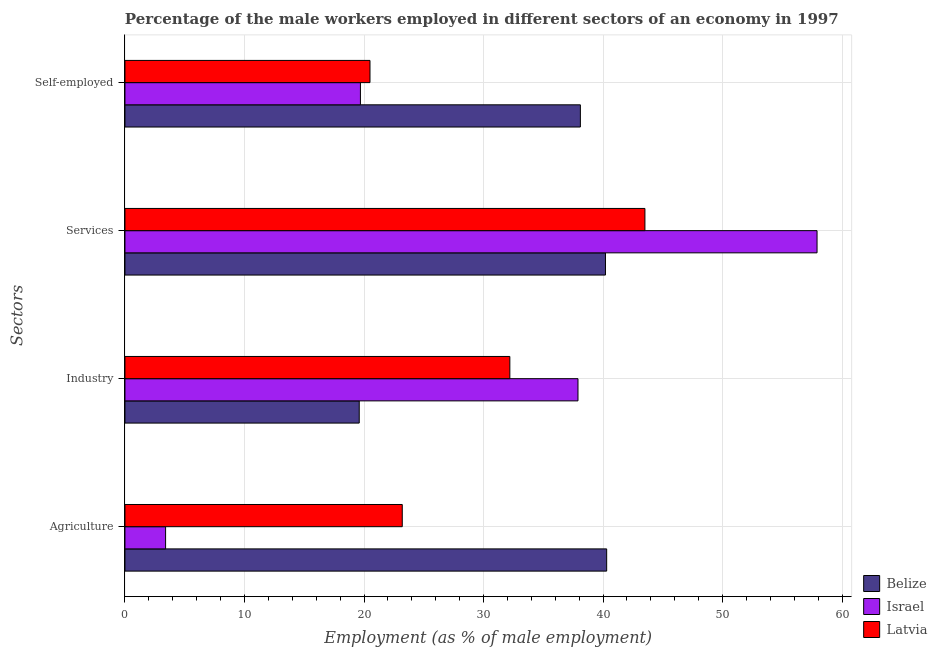How many groups of bars are there?
Offer a terse response. 4. Are the number of bars on each tick of the Y-axis equal?
Make the answer very short. Yes. How many bars are there on the 2nd tick from the bottom?
Provide a succinct answer. 3. What is the label of the 3rd group of bars from the top?
Your response must be concise. Industry. What is the percentage of self employed male workers in Latvia?
Give a very brief answer. 20.5. Across all countries, what is the maximum percentage of male workers in services?
Make the answer very short. 57.9. Across all countries, what is the minimum percentage of male workers in industry?
Your answer should be very brief. 19.6. In which country was the percentage of self employed male workers maximum?
Ensure brevity in your answer.  Belize. In which country was the percentage of male workers in agriculture minimum?
Offer a terse response. Israel. What is the total percentage of male workers in agriculture in the graph?
Ensure brevity in your answer.  66.9. What is the difference between the percentage of male workers in industry in Belize and that in Latvia?
Provide a short and direct response. -12.6. What is the difference between the percentage of male workers in services in Latvia and the percentage of male workers in agriculture in Israel?
Your answer should be very brief. 40.1. What is the average percentage of self employed male workers per country?
Your answer should be very brief. 26.1. What is the difference between the percentage of male workers in agriculture and percentage of self employed male workers in Israel?
Ensure brevity in your answer.  -16.3. In how many countries, is the percentage of male workers in services greater than 28 %?
Offer a terse response. 3. What is the ratio of the percentage of self employed male workers in Latvia to that in Israel?
Ensure brevity in your answer.  1.04. Is the difference between the percentage of male workers in services in Belize and Israel greater than the difference between the percentage of male workers in industry in Belize and Israel?
Your answer should be compact. Yes. What is the difference between the highest and the second highest percentage of self employed male workers?
Provide a succinct answer. 17.6. What is the difference between the highest and the lowest percentage of male workers in industry?
Your answer should be compact. 18.3. Is it the case that in every country, the sum of the percentage of self employed male workers and percentage of male workers in industry is greater than the sum of percentage of male workers in services and percentage of male workers in agriculture?
Offer a very short reply. No. What does the 1st bar from the bottom in Agriculture represents?
Provide a short and direct response. Belize. How many bars are there?
Your answer should be compact. 12. Are all the bars in the graph horizontal?
Ensure brevity in your answer.  Yes. Are the values on the major ticks of X-axis written in scientific E-notation?
Ensure brevity in your answer.  No. Where does the legend appear in the graph?
Provide a short and direct response. Bottom right. What is the title of the graph?
Offer a very short reply. Percentage of the male workers employed in different sectors of an economy in 1997. Does "Guinea" appear as one of the legend labels in the graph?
Offer a very short reply. No. What is the label or title of the X-axis?
Keep it short and to the point. Employment (as % of male employment). What is the label or title of the Y-axis?
Keep it short and to the point. Sectors. What is the Employment (as % of male employment) of Belize in Agriculture?
Your answer should be compact. 40.3. What is the Employment (as % of male employment) in Israel in Agriculture?
Make the answer very short. 3.4. What is the Employment (as % of male employment) in Latvia in Agriculture?
Your response must be concise. 23.2. What is the Employment (as % of male employment) of Belize in Industry?
Provide a short and direct response. 19.6. What is the Employment (as % of male employment) in Israel in Industry?
Give a very brief answer. 37.9. What is the Employment (as % of male employment) of Latvia in Industry?
Ensure brevity in your answer.  32.2. What is the Employment (as % of male employment) of Belize in Services?
Give a very brief answer. 40.2. What is the Employment (as % of male employment) of Israel in Services?
Ensure brevity in your answer.  57.9. What is the Employment (as % of male employment) of Latvia in Services?
Offer a very short reply. 43.5. What is the Employment (as % of male employment) in Belize in Self-employed?
Your answer should be compact. 38.1. What is the Employment (as % of male employment) in Israel in Self-employed?
Offer a terse response. 19.7. What is the Employment (as % of male employment) in Latvia in Self-employed?
Offer a terse response. 20.5. Across all Sectors, what is the maximum Employment (as % of male employment) in Belize?
Offer a very short reply. 40.3. Across all Sectors, what is the maximum Employment (as % of male employment) in Israel?
Provide a succinct answer. 57.9. Across all Sectors, what is the maximum Employment (as % of male employment) of Latvia?
Make the answer very short. 43.5. Across all Sectors, what is the minimum Employment (as % of male employment) in Belize?
Your answer should be compact. 19.6. Across all Sectors, what is the minimum Employment (as % of male employment) of Israel?
Provide a short and direct response. 3.4. Across all Sectors, what is the minimum Employment (as % of male employment) in Latvia?
Offer a very short reply. 20.5. What is the total Employment (as % of male employment) of Belize in the graph?
Keep it short and to the point. 138.2. What is the total Employment (as % of male employment) in Israel in the graph?
Keep it short and to the point. 118.9. What is the total Employment (as % of male employment) in Latvia in the graph?
Offer a very short reply. 119.4. What is the difference between the Employment (as % of male employment) of Belize in Agriculture and that in Industry?
Provide a short and direct response. 20.7. What is the difference between the Employment (as % of male employment) in Israel in Agriculture and that in Industry?
Ensure brevity in your answer.  -34.5. What is the difference between the Employment (as % of male employment) in Belize in Agriculture and that in Services?
Give a very brief answer. 0.1. What is the difference between the Employment (as % of male employment) in Israel in Agriculture and that in Services?
Offer a very short reply. -54.5. What is the difference between the Employment (as % of male employment) in Latvia in Agriculture and that in Services?
Provide a succinct answer. -20.3. What is the difference between the Employment (as % of male employment) of Belize in Agriculture and that in Self-employed?
Your answer should be very brief. 2.2. What is the difference between the Employment (as % of male employment) of Israel in Agriculture and that in Self-employed?
Your response must be concise. -16.3. What is the difference between the Employment (as % of male employment) in Belize in Industry and that in Services?
Offer a very short reply. -20.6. What is the difference between the Employment (as % of male employment) in Israel in Industry and that in Services?
Give a very brief answer. -20. What is the difference between the Employment (as % of male employment) in Latvia in Industry and that in Services?
Offer a very short reply. -11.3. What is the difference between the Employment (as % of male employment) in Belize in Industry and that in Self-employed?
Offer a terse response. -18.5. What is the difference between the Employment (as % of male employment) of Belize in Services and that in Self-employed?
Your response must be concise. 2.1. What is the difference between the Employment (as % of male employment) in Israel in Services and that in Self-employed?
Make the answer very short. 38.2. What is the difference between the Employment (as % of male employment) in Belize in Agriculture and the Employment (as % of male employment) in Israel in Industry?
Provide a short and direct response. 2.4. What is the difference between the Employment (as % of male employment) of Israel in Agriculture and the Employment (as % of male employment) of Latvia in Industry?
Provide a short and direct response. -28.8. What is the difference between the Employment (as % of male employment) of Belize in Agriculture and the Employment (as % of male employment) of Israel in Services?
Provide a short and direct response. -17.6. What is the difference between the Employment (as % of male employment) of Israel in Agriculture and the Employment (as % of male employment) of Latvia in Services?
Offer a terse response. -40.1. What is the difference between the Employment (as % of male employment) in Belize in Agriculture and the Employment (as % of male employment) in Israel in Self-employed?
Your answer should be compact. 20.6. What is the difference between the Employment (as % of male employment) in Belize in Agriculture and the Employment (as % of male employment) in Latvia in Self-employed?
Your answer should be very brief. 19.8. What is the difference between the Employment (as % of male employment) of Israel in Agriculture and the Employment (as % of male employment) of Latvia in Self-employed?
Ensure brevity in your answer.  -17.1. What is the difference between the Employment (as % of male employment) in Belize in Industry and the Employment (as % of male employment) in Israel in Services?
Give a very brief answer. -38.3. What is the difference between the Employment (as % of male employment) in Belize in Industry and the Employment (as % of male employment) in Latvia in Services?
Offer a terse response. -23.9. What is the difference between the Employment (as % of male employment) of Israel in Industry and the Employment (as % of male employment) of Latvia in Services?
Give a very brief answer. -5.6. What is the difference between the Employment (as % of male employment) of Israel in Industry and the Employment (as % of male employment) of Latvia in Self-employed?
Keep it short and to the point. 17.4. What is the difference between the Employment (as % of male employment) in Israel in Services and the Employment (as % of male employment) in Latvia in Self-employed?
Your answer should be compact. 37.4. What is the average Employment (as % of male employment) of Belize per Sectors?
Provide a short and direct response. 34.55. What is the average Employment (as % of male employment) of Israel per Sectors?
Give a very brief answer. 29.73. What is the average Employment (as % of male employment) of Latvia per Sectors?
Offer a very short reply. 29.85. What is the difference between the Employment (as % of male employment) in Belize and Employment (as % of male employment) in Israel in Agriculture?
Give a very brief answer. 36.9. What is the difference between the Employment (as % of male employment) in Israel and Employment (as % of male employment) in Latvia in Agriculture?
Give a very brief answer. -19.8. What is the difference between the Employment (as % of male employment) in Belize and Employment (as % of male employment) in Israel in Industry?
Your answer should be compact. -18.3. What is the difference between the Employment (as % of male employment) in Belize and Employment (as % of male employment) in Israel in Services?
Your response must be concise. -17.7. What is the difference between the Employment (as % of male employment) of Belize and Employment (as % of male employment) of Latvia in Services?
Your answer should be very brief. -3.3. What is the difference between the Employment (as % of male employment) of Israel and Employment (as % of male employment) of Latvia in Services?
Your answer should be very brief. 14.4. What is the difference between the Employment (as % of male employment) in Israel and Employment (as % of male employment) in Latvia in Self-employed?
Your answer should be compact. -0.8. What is the ratio of the Employment (as % of male employment) of Belize in Agriculture to that in Industry?
Offer a very short reply. 2.06. What is the ratio of the Employment (as % of male employment) of Israel in Agriculture to that in Industry?
Ensure brevity in your answer.  0.09. What is the ratio of the Employment (as % of male employment) in Latvia in Agriculture to that in Industry?
Your answer should be compact. 0.72. What is the ratio of the Employment (as % of male employment) in Israel in Agriculture to that in Services?
Offer a terse response. 0.06. What is the ratio of the Employment (as % of male employment) in Latvia in Agriculture to that in Services?
Provide a succinct answer. 0.53. What is the ratio of the Employment (as % of male employment) of Belize in Agriculture to that in Self-employed?
Provide a succinct answer. 1.06. What is the ratio of the Employment (as % of male employment) of Israel in Agriculture to that in Self-employed?
Your answer should be compact. 0.17. What is the ratio of the Employment (as % of male employment) in Latvia in Agriculture to that in Self-employed?
Offer a very short reply. 1.13. What is the ratio of the Employment (as % of male employment) of Belize in Industry to that in Services?
Offer a terse response. 0.49. What is the ratio of the Employment (as % of male employment) of Israel in Industry to that in Services?
Offer a terse response. 0.65. What is the ratio of the Employment (as % of male employment) of Latvia in Industry to that in Services?
Offer a terse response. 0.74. What is the ratio of the Employment (as % of male employment) of Belize in Industry to that in Self-employed?
Provide a succinct answer. 0.51. What is the ratio of the Employment (as % of male employment) of Israel in Industry to that in Self-employed?
Your answer should be compact. 1.92. What is the ratio of the Employment (as % of male employment) of Latvia in Industry to that in Self-employed?
Make the answer very short. 1.57. What is the ratio of the Employment (as % of male employment) of Belize in Services to that in Self-employed?
Provide a short and direct response. 1.06. What is the ratio of the Employment (as % of male employment) of Israel in Services to that in Self-employed?
Give a very brief answer. 2.94. What is the ratio of the Employment (as % of male employment) of Latvia in Services to that in Self-employed?
Make the answer very short. 2.12. What is the difference between the highest and the second highest Employment (as % of male employment) in Latvia?
Your response must be concise. 11.3. What is the difference between the highest and the lowest Employment (as % of male employment) of Belize?
Keep it short and to the point. 20.7. What is the difference between the highest and the lowest Employment (as % of male employment) of Israel?
Offer a very short reply. 54.5. 